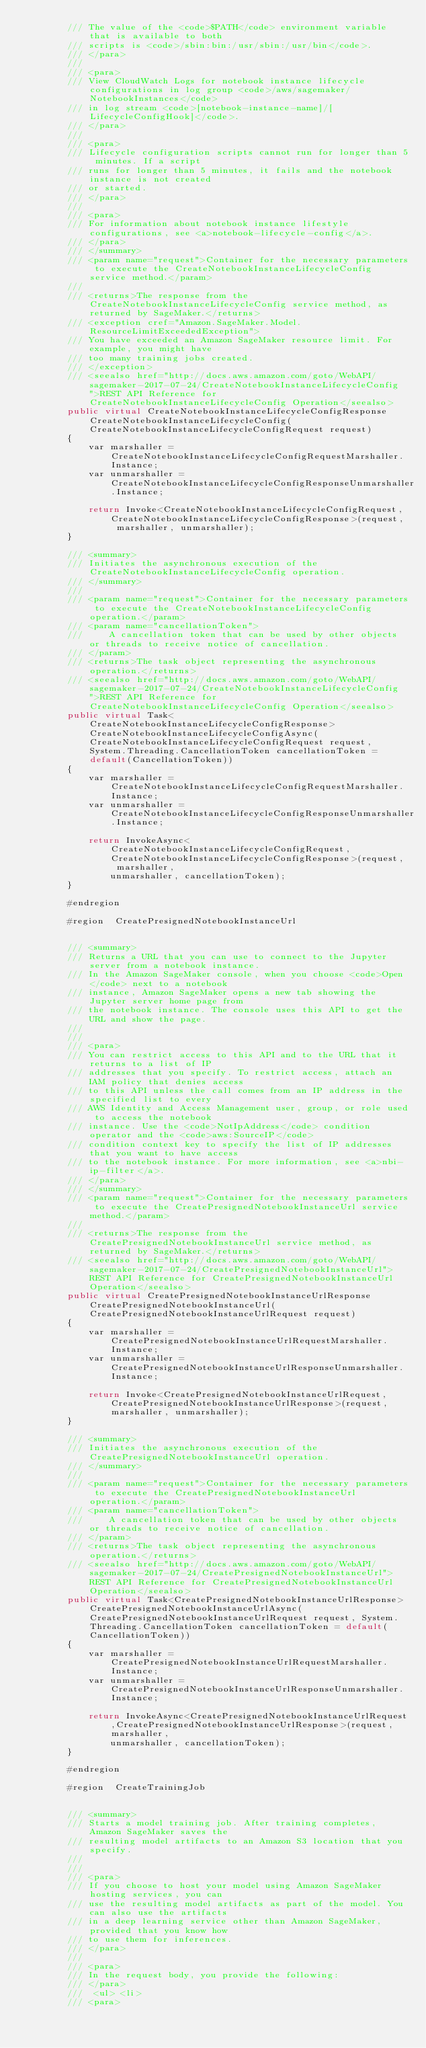Convert code to text. <code><loc_0><loc_0><loc_500><loc_500><_C#_>        /// The value of the <code>$PATH</code> environment variable that is available to both
        /// scripts is <code>/sbin:bin:/usr/sbin:/usr/bin</code>.
        /// </para>
        ///  
        /// <para>
        /// View CloudWatch Logs for notebook instance lifecycle configurations in log group <code>/aws/sagemaker/NotebookInstances</code>
        /// in log stream <code>[notebook-instance-name]/[LifecycleConfigHook]</code>.
        /// </para>
        ///  
        /// <para>
        /// Lifecycle configuration scripts cannot run for longer than 5 minutes. If a script
        /// runs for longer than 5 minutes, it fails and the notebook instance is not created
        /// or started.
        /// </para>
        ///  
        /// <para>
        /// For information about notebook instance lifestyle configurations, see <a>notebook-lifecycle-config</a>.
        /// </para>
        /// </summary>
        /// <param name="request">Container for the necessary parameters to execute the CreateNotebookInstanceLifecycleConfig service method.</param>
        /// 
        /// <returns>The response from the CreateNotebookInstanceLifecycleConfig service method, as returned by SageMaker.</returns>
        /// <exception cref="Amazon.SageMaker.Model.ResourceLimitExceededException">
        /// You have exceeded an Amazon SageMaker resource limit. For example, you might have
        /// too many training jobs created.
        /// </exception>
        /// <seealso href="http://docs.aws.amazon.com/goto/WebAPI/sagemaker-2017-07-24/CreateNotebookInstanceLifecycleConfig">REST API Reference for CreateNotebookInstanceLifecycleConfig Operation</seealso>
        public virtual CreateNotebookInstanceLifecycleConfigResponse CreateNotebookInstanceLifecycleConfig(CreateNotebookInstanceLifecycleConfigRequest request)
        {
            var marshaller = CreateNotebookInstanceLifecycleConfigRequestMarshaller.Instance;
            var unmarshaller = CreateNotebookInstanceLifecycleConfigResponseUnmarshaller.Instance;

            return Invoke<CreateNotebookInstanceLifecycleConfigRequest,CreateNotebookInstanceLifecycleConfigResponse>(request, marshaller, unmarshaller);
        }

        /// <summary>
        /// Initiates the asynchronous execution of the CreateNotebookInstanceLifecycleConfig operation.
        /// </summary>
        /// 
        /// <param name="request">Container for the necessary parameters to execute the CreateNotebookInstanceLifecycleConfig operation.</param>
        /// <param name="cancellationToken">
        ///     A cancellation token that can be used by other objects or threads to receive notice of cancellation.
        /// </param>
        /// <returns>The task object representing the asynchronous operation.</returns>
        /// <seealso href="http://docs.aws.amazon.com/goto/WebAPI/sagemaker-2017-07-24/CreateNotebookInstanceLifecycleConfig">REST API Reference for CreateNotebookInstanceLifecycleConfig Operation</seealso>
        public virtual Task<CreateNotebookInstanceLifecycleConfigResponse> CreateNotebookInstanceLifecycleConfigAsync(CreateNotebookInstanceLifecycleConfigRequest request, System.Threading.CancellationToken cancellationToken = default(CancellationToken))
        {
            var marshaller = CreateNotebookInstanceLifecycleConfigRequestMarshaller.Instance;
            var unmarshaller = CreateNotebookInstanceLifecycleConfigResponseUnmarshaller.Instance;

            return InvokeAsync<CreateNotebookInstanceLifecycleConfigRequest,CreateNotebookInstanceLifecycleConfigResponse>(request, marshaller, 
                unmarshaller, cancellationToken);
        }

        #endregion
        
        #region  CreatePresignedNotebookInstanceUrl


        /// <summary>
        /// Returns a URL that you can use to connect to the Jupyter server from a notebook instance.
        /// In the Amazon SageMaker console, when you choose <code>Open</code> next to a notebook
        /// instance, Amazon SageMaker opens a new tab showing the Jupyter server home page from
        /// the notebook instance. The console uses this API to get the URL and show the page.
        /// 
        ///  
        /// <para>
        /// You can restrict access to this API and to the URL that it returns to a list of IP
        /// addresses that you specify. To restrict access, attach an IAM policy that denies access
        /// to this API unless the call comes from an IP address in the specified list to every
        /// AWS Identity and Access Management user, group, or role used to access the notebook
        /// instance. Use the <code>NotIpAddress</code> condition operator and the <code>aws:SourceIP</code>
        /// condition context key to specify the list of IP addresses that you want to have access
        /// to the notebook instance. For more information, see <a>nbi-ip-filter</a>.
        /// </para>
        /// </summary>
        /// <param name="request">Container for the necessary parameters to execute the CreatePresignedNotebookInstanceUrl service method.</param>
        /// 
        /// <returns>The response from the CreatePresignedNotebookInstanceUrl service method, as returned by SageMaker.</returns>
        /// <seealso href="http://docs.aws.amazon.com/goto/WebAPI/sagemaker-2017-07-24/CreatePresignedNotebookInstanceUrl">REST API Reference for CreatePresignedNotebookInstanceUrl Operation</seealso>
        public virtual CreatePresignedNotebookInstanceUrlResponse CreatePresignedNotebookInstanceUrl(CreatePresignedNotebookInstanceUrlRequest request)
        {
            var marshaller = CreatePresignedNotebookInstanceUrlRequestMarshaller.Instance;
            var unmarshaller = CreatePresignedNotebookInstanceUrlResponseUnmarshaller.Instance;

            return Invoke<CreatePresignedNotebookInstanceUrlRequest,CreatePresignedNotebookInstanceUrlResponse>(request, marshaller, unmarshaller);
        }

        /// <summary>
        /// Initiates the asynchronous execution of the CreatePresignedNotebookInstanceUrl operation.
        /// </summary>
        /// 
        /// <param name="request">Container for the necessary parameters to execute the CreatePresignedNotebookInstanceUrl operation.</param>
        /// <param name="cancellationToken">
        ///     A cancellation token that can be used by other objects or threads to receive notice of cancellation.
        /// </param>
        /// <returns>The task object representing the asynchronous operation.</returns>
        /// <seealso href="http://docs.aws.amazon.com/goto/WebAPI/sagemaker-2017-07-24/CreatePresignedNotebookInstanceUrl">REST API Reference for CreatePresignedNotebookInstanceUrl Operation</seealso>
        public virtual Task<CreatePresignedNotebookInstanceUrlResponse> CreatePresignedNotebookInstanceUrlAsync(CreatePresignedNotebookInstanceUrlRequest request, System.Threading.CancellationToken cancellationToken = default(CancellationToken))
        {
            var marshaller = CreatePresignedNotebookInstanceUrlRequestMarshaller.Instance;
            var unmarshaller = CreatePresignedNotebookInstanceUrlResponseUnmarshaller.Instance;

            return InvokeAsync<CreatePresignedNotebookInstanceUrlRequest,CreatePresignedNotebookInstanceUrlResponse>(request, marshaller, 
                unmarshaller, cancellationToken);
        }

        #endregion
        
        #region  CreateTrainingJob


        /// <summary>
        /// Starts a model training job. After training completes, Amazon SageMaker saves the
        /// resulting model artifacts to an Amazon S3 location that you specify. 
        /// 
        ///  
        /// <para>
        /// If you choose to host your model using Amazon SageMaker hosting services, you can
        /// use the resulting model artifacts as part of the model. You can also use the artifacts
        /// in a deep learning service other than Amazon SageMaker, provided that you know how
        /// to use them for inferences. 
        /// </para>
        ///  
        /// <para>
        /// In the request body, you provide the following: 
        /// </para>
        ///  <ul> <li> 
        /// <para></code> 